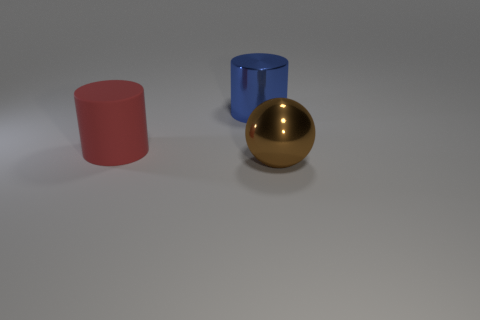Subtract all blue cylinders. How many cylinders are left? 1 Add 2 blue metallic things. How many objects exist? 5 Subtract all balls. How many objects are left? 2 Subtract 1 cylinders. How many cylinders are left? 1 Subtract all purple cubes. Subtract all big cylinders. How many objects are left? 1 Add 3 metallic balls. How many metallic balls are left? 4 Add 1 large brown things. How many large brown things exist? 2 Subtract 1 blue cylinders. How many objects are left? 2 Subtract all yellow spheres. Subtract all cyan cylinders. How many spheres are left? 1 Subtract all gray balls. How many gray cylinders are left? 0 